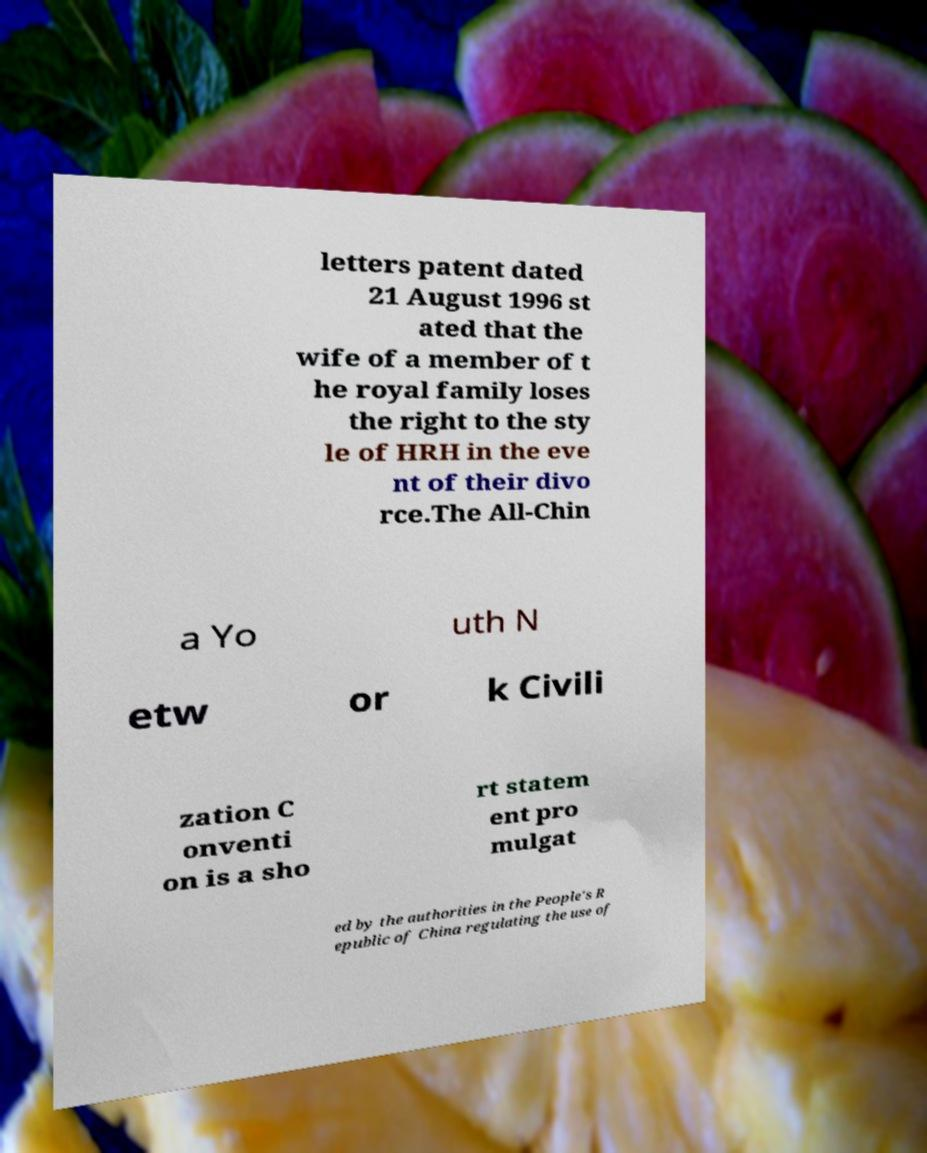Could you extract and type out the text from this image? letters patent dated 21 August 1996 st ated that the wife of a member of t he royal family loses the right to the sty le of HRH in the eve nt of their divo rce.The All-Chin a Yo uth N etw or k Civili zation C onventi on is a sho rt statem ent pro mulgat ed by the authorities in the People's R epublic of China regulating the use of 